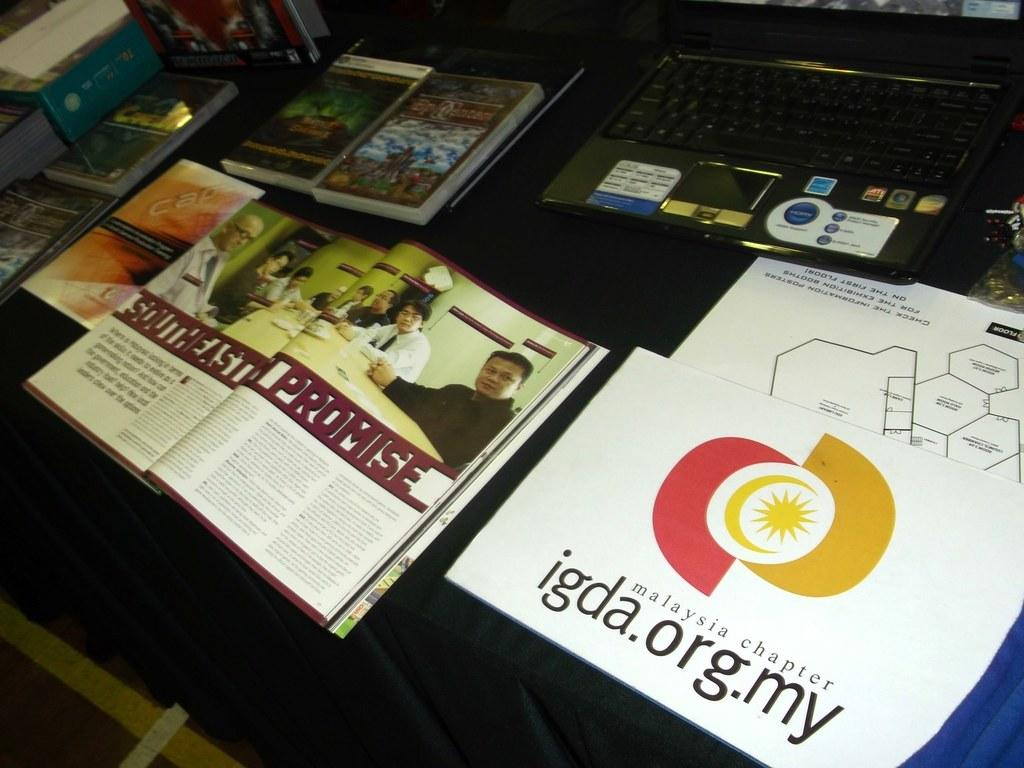Provide a one-sentence caption for the provided image. A table with a laptop, several various books, an open book depicting the Southeast Promise, and a Malaysia chapter igda.org.my booklet. 